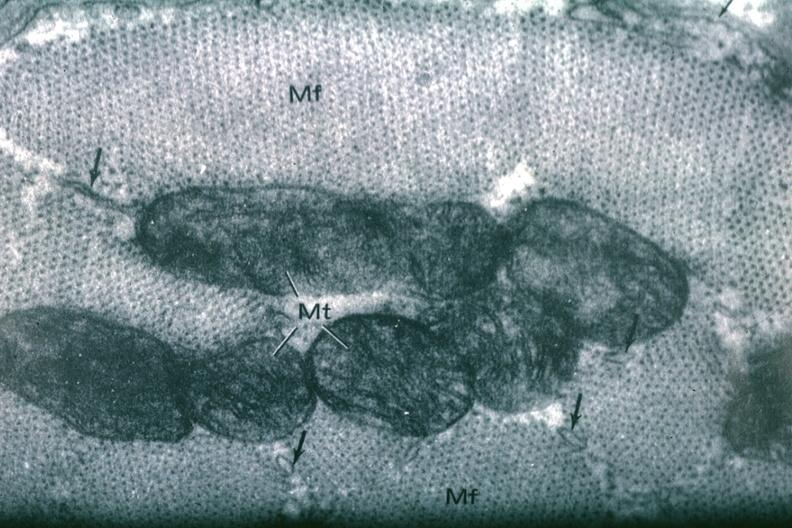s myocardium present?
Answer the question using a single word or phrase. Yes 